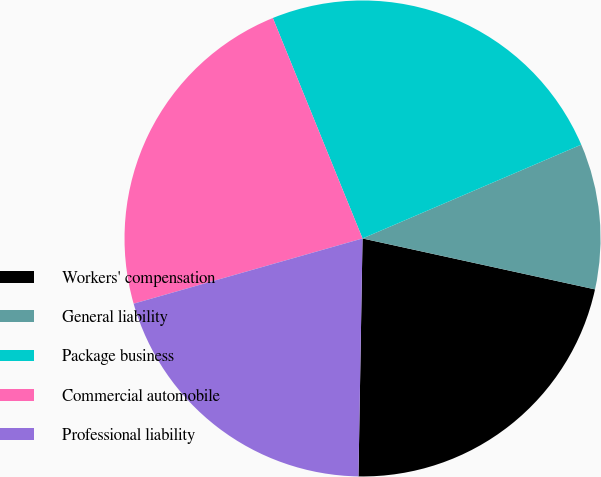Convert chart to OTSL. <chart><loc_0><loc_0><loc_500><loc_500><pie_chart><fcel>Workers' compensation<fcel>General liability<fcel>Package business<fcel>Commercial automobile<fcel>Professional liability<nl><fcel>21.84%<fcel>9.88%<fcel>24.7%<fcel>23.27%<fcel>20.31%<nl></chart> 